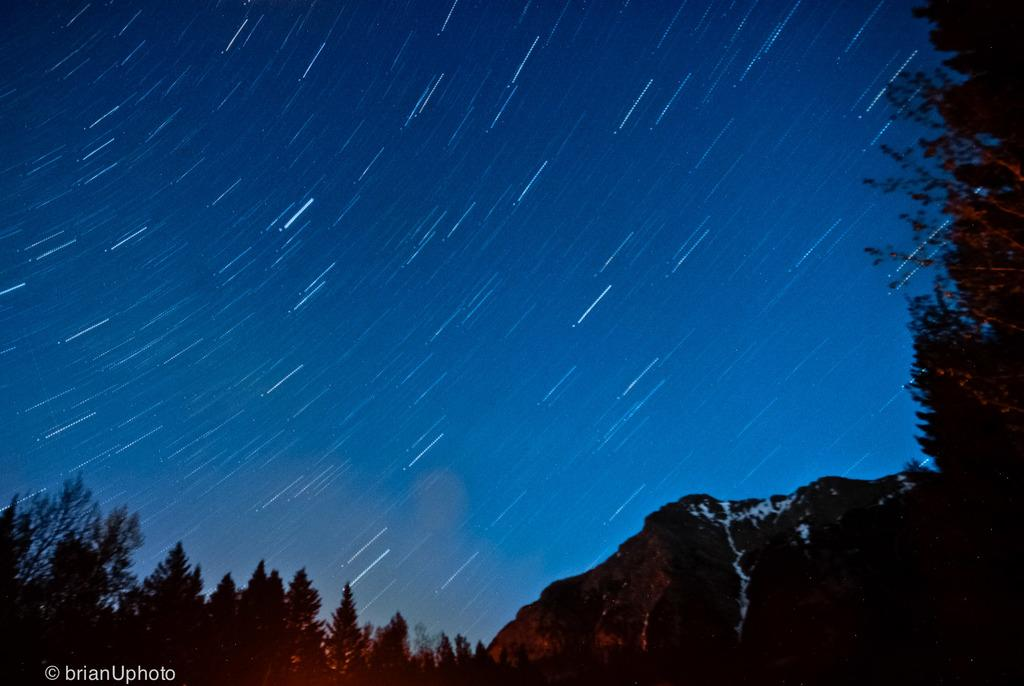What type of vegetation can be seen in the image? There are trees in the image. What part of the natural environment is visible in the image? The sky is visible in the image. Where is the text located in the image? The text is on the bottom left of the image. How many women are walking down the alley in the image? There is no alley or women present in the image; it features trees and text. 